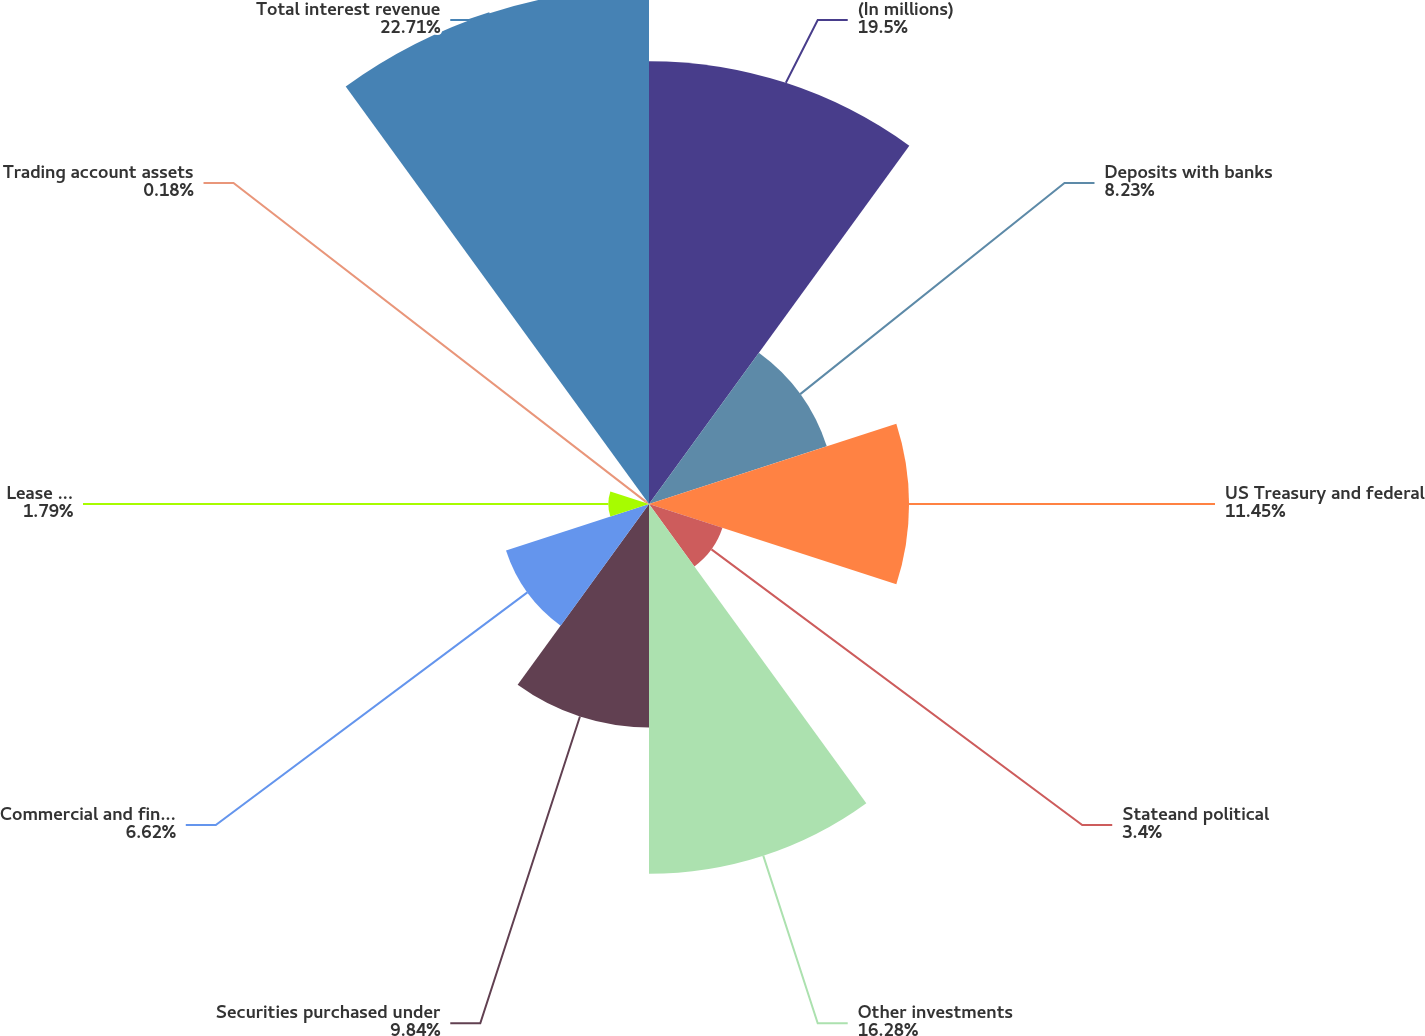<chart> <loc_0><loc_0><loc_500><loc_500><pie_chart><fcel>(In millions)<fcel>Deposits with banks<fcel>US Treasury and federal<fcel>Stateand political<fcel>Other investments<fcel>Securities purchased under<fcel>Commercial and financial loans<fcel>Lease financing<fcel>Trading account assets<fcel>Total interest revenue<nl><fcel>19.5%<fcel>8.23%<fcel>11.45%<fcel>3.4%<fcel>16.28%<fcel>9.84%<fcel>6.62%<fcel>1.79%<fcel>0.18%<fcel>22.72%<nl></chart> 